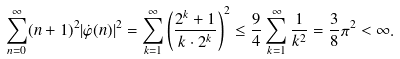Convert formula to latex. <formula><loc_0><loc_0><loc_500><loc_500>\sum _ { n = 0 } ^ { \infty } ( n + 1 ) ^ { 2 } | \dot { \varphi } ( n ) | ^ { 2 } = \sum _ { k = 1 } ^ { \infty } \left ( \frac { 2 ^ { k } + 1 } { k \cdot 2 ^ { k } } \right ) ^ { 2 } \leq \frac { 9 } { 4 } \sum _ { k = 1 } ^ { \infty } \frac { 1 } { k ^ { 2 } } = \frac { 3 } { 8 } \pi ^ { 2 } < \infty .</formula> 